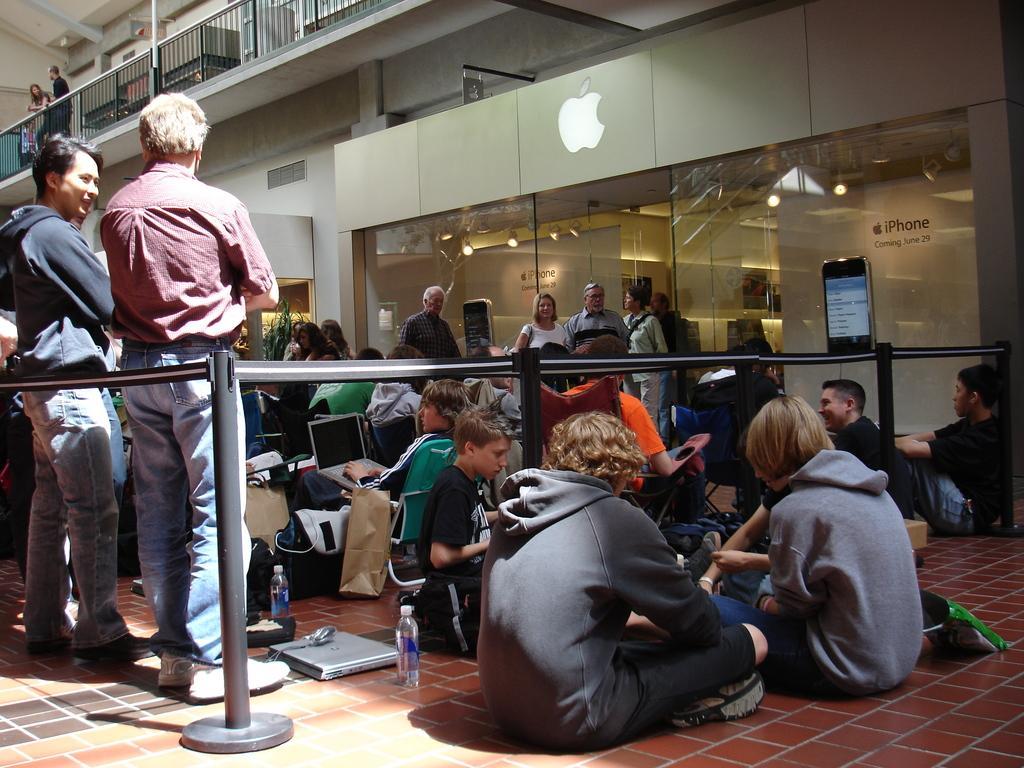Please provide a concise description of this image. In this image we can see people standing on the floor and some are sitting on the ground. On the ground we can see laptops, disposable bottles and backpacks. In addition to this we can see name boards, railings, information boards and barrier poles. 